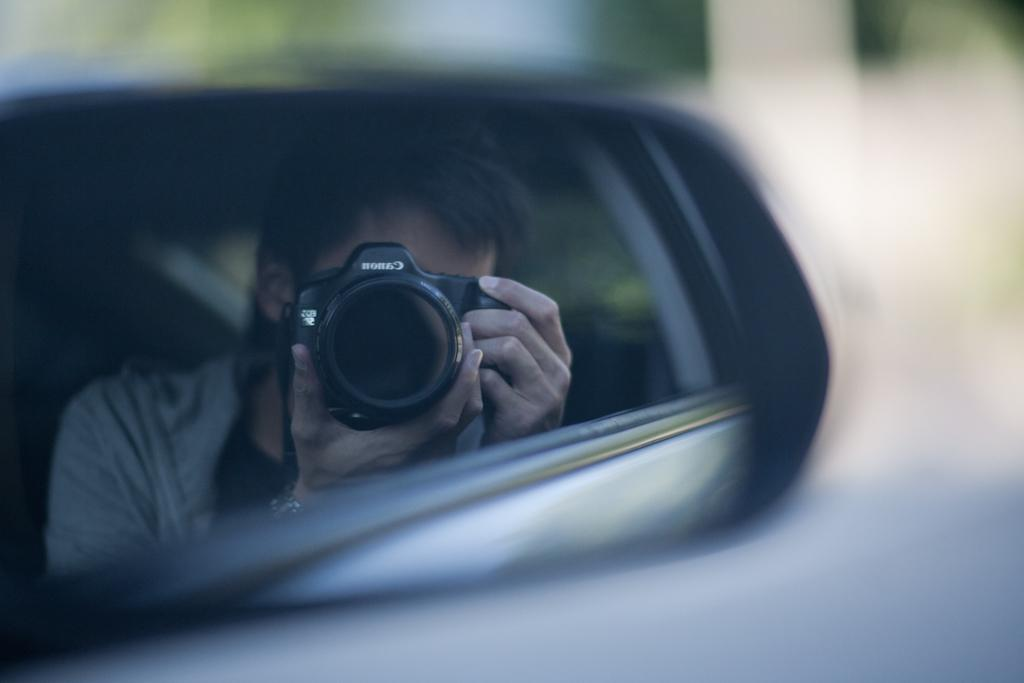What object is located on the left side of the image? There is a mirror on the left side of the image. What can be seen in the mirror? A person is visible in the mirror. What is the person holding in their hands? The person is holding a camera in their hands. How is the background in the mirror depicted? The background in the mirror is blurred. How does the person wash their chin in the image? There is no indication in the image that the person is washing their chin, as they are holding a camera and not performing any such action. 